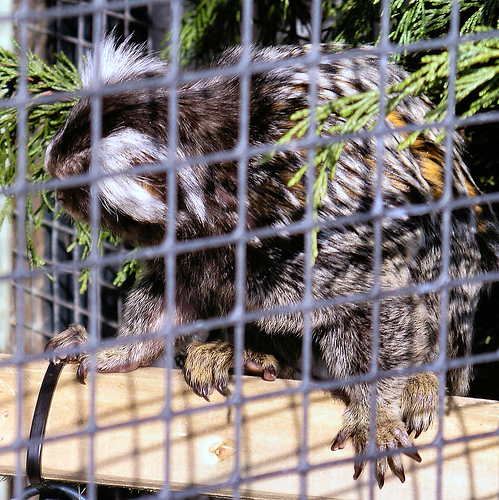<image>
Is there a animal behind the fence? Yes. From this viewpoint, the animal is positioned behind the fence, with the fence partially or fully occluding the animal. 